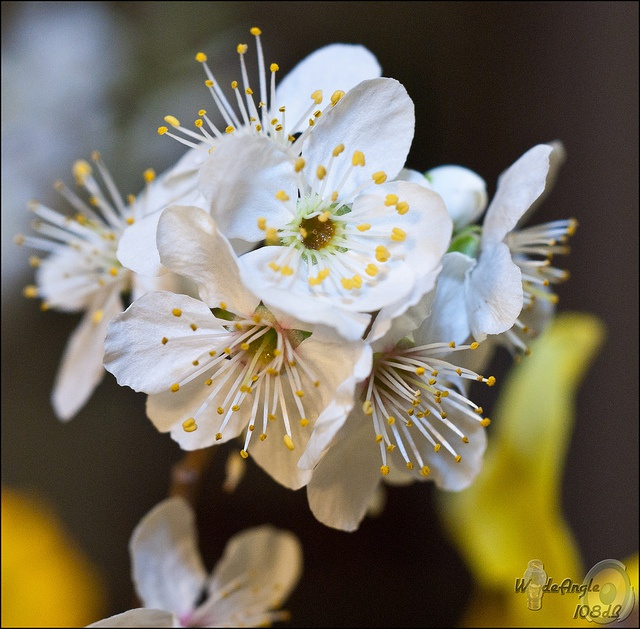Describe the objects in this image and their specific colors. I can see a potted plant in black, lavender, darkgray, and gray tones in this image. 